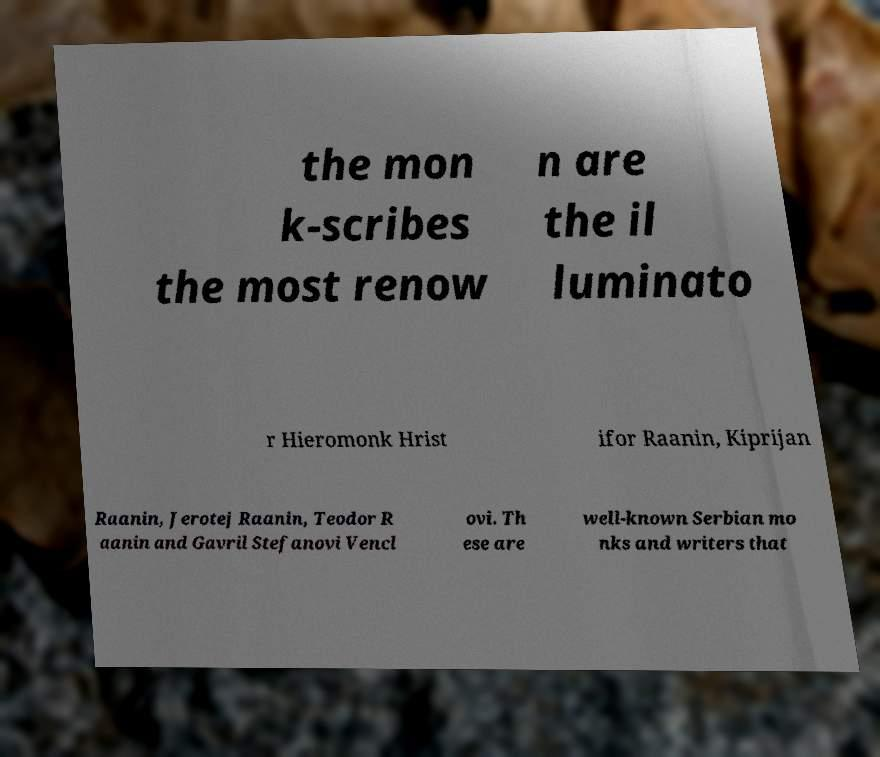Can you accurately transcribe the text from the provided image for me? the mon k-scribes the most renow n are the il luminato r Hieromonk Hrist ifor Raanin, Kiprijan Raanin, Jerotej Raanin, Teodor R aanin and Gavril Stefanovi Vencl ovi. Th ese are well-known Serbian mo nks and writers that 